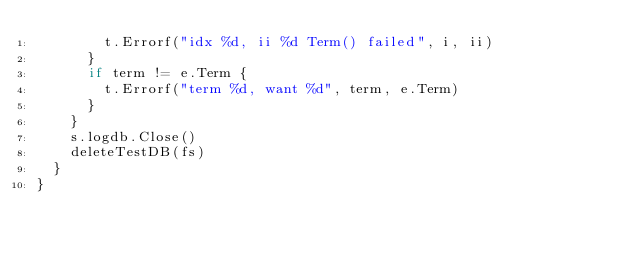Convert code to text. <code><loc_0><loc_0><loc_500><loc_500><_Go_>				t.Errorf("idx %d, ii %d Term() failed", i, ii)
			}
			if term != e.Term {
				t.Errorf("term %d, want %d", term, e.Term)
			}
		}
		s.logdb.Close()
		deleteTestDB(fs)
	}
}
</code> 